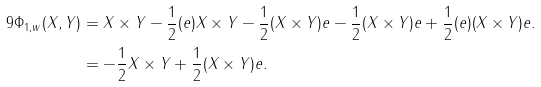Convert formula to latex. <formula><loc_0><loc_0><loc_500><loc_500>9 \Phi _ { 1 , w } ( X , Y ) & = X \times Y - \frac { 1 } { 2 } ( e ) X \times Y - \frac { 1 } { 2 } ( X \times Y ) e - \frac { 1 } { 2 } ( X \times Y ) e + \frac { 1 } { 2 } ( e ) ( X \times Y ) e . \\ & = - \frac { 1 } { 2 } X \times Y + \frac { 1 } { 2 } ( X \times Y ) e .</formula> 